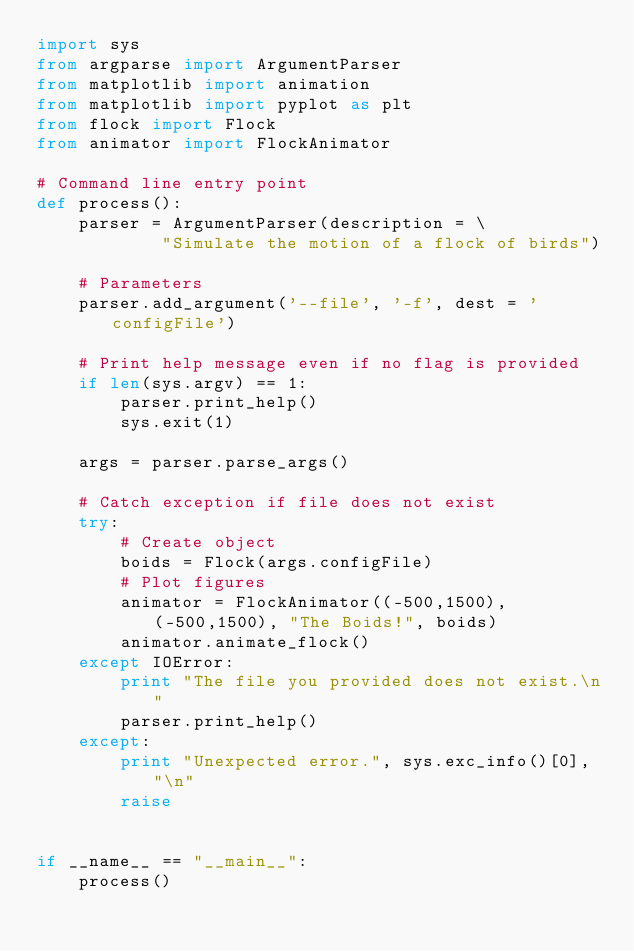Convert code to text. <code><loc_0><loc_0><loc_500><loc_500><_Python_>import sys
from argparse import ArgumentParser
from matplotlib import animation
from matplotlib import pyplot as plt
from flock import Flock
from animator import FlockAnimator

# Command line entry point
def process():
    parser = ArgumentParser(description = \
            "Simulate the motion of a flock of birds")
    
    # Parameters
    parser.add_argument('--file', '-f', dest = 'configFile')

    # Print help message even if no flag is provided
    if len(sys.argv) == 1:
        parser.print_help()
        sys.exit(1)

    args = parser.parse_args()

    # Catch exception if file does not exist
    try:
        # Create object
        boids = Flock(args.configFile)
        # Plot figures
        animator = FlockAnimator((-500,1500), (-500,1500), "The Boids!", boids)
        animator.animate_flock()
    except IOError:
        print "The file you provided does not exist.\n" 
        parser.print_help()
    except:
        print "Unexpected error.", sys.exc_info()[0], "\n"
        raise


if __name__ == "__main__":
    process()

</code> 